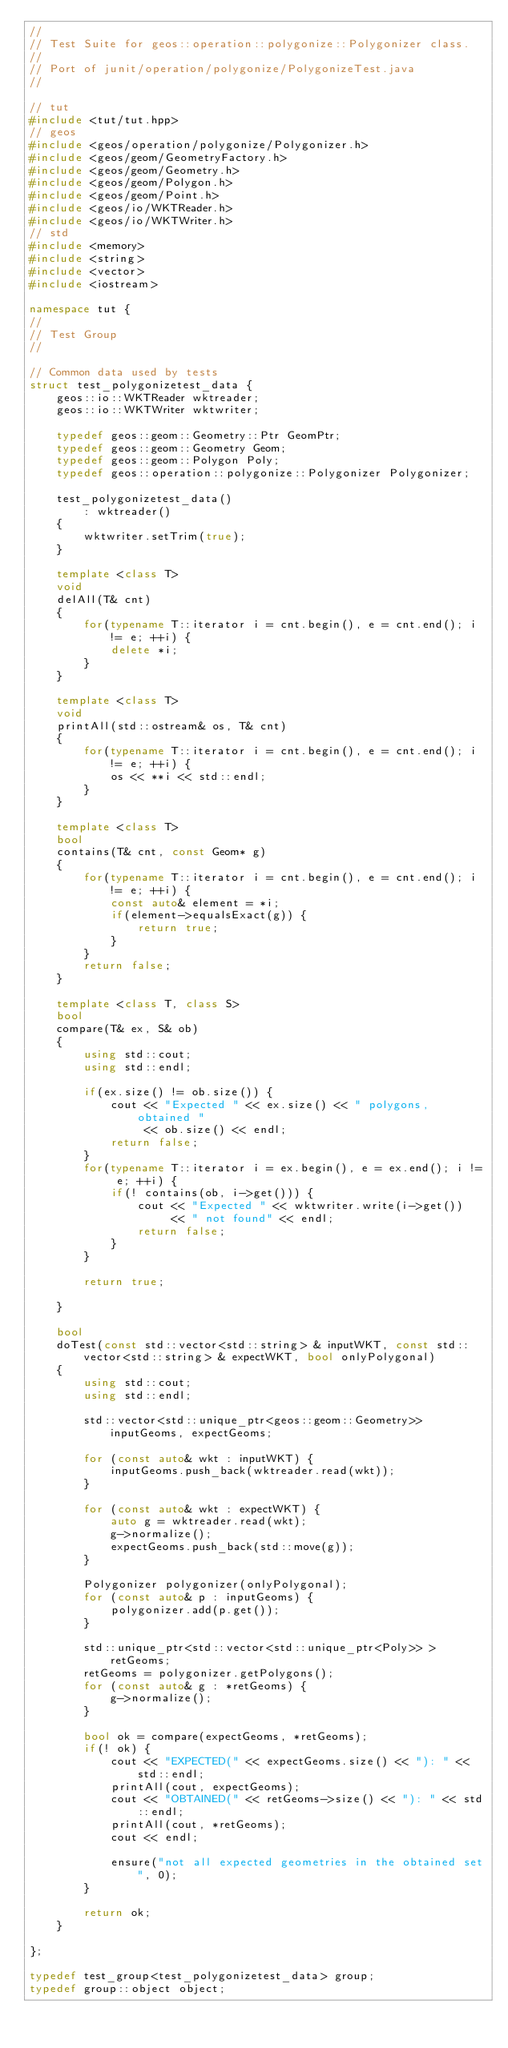<code> <loc_0><loc_0><loc_500><loc_500><_C++_>//
// Test Suite for geos::operation::polygonize::Polygonizer class.
//
// Port of junit/operation/polygonize/PolygonizeTest.java
//

// tut
#include <tut/tut.hpp>
// geos
#include <geos/operation/polygonize/Polygonizer.h>
#include <geos/geom/GeometryFactory.h>
#include <geos/geom/Geometry.h>
#include <geos/geom/Polygon.h>
#include <geos/geom/Point.h>
#include <geos/io/WKTReader.h>
#include <geos/io/WKTWriter.h>
// std
#include <memory>
#include <string>
#include <vector>
#include <iostream>

namespace tut {
//
// Test Group
//

// Common data used by tests
struct test_polygonizetest_data {
    geos::io::WKTReader wktreader;
    geos::io::WKTWriter wktwriter;

    typedef geos::geom::Geometry::Ptr GeomPtr;
    typedef geos::geom::Geometry Geom;
    typedef geos::geom::Polygon Poly;
    typedef geos::operation::polygonize::Polygonizer Polygonizer;

    test_polygonizetest_data()
        : wktreader()
    {
        wktwriter.setTrim(true);
    }

    template <class T>
    void
    delAll(T& cnt)
    {
        for(typename T::iterator i = cnt.begin(), e = cnt.end(); i != e; ++i) {
            delete *i;
        }
    }

    template <class T>
    void
    printAll(std::ostream& os, T& cnt)
    {
        for(typename T::iterator i = cnt.begin(), e = cnt.end(); i != e; ++i) {
            os << **i << std::endl;
        }
    }

    template <class T>
    bool
    contains(T& cnt, const Geom* g)
    {
        for(typename T::iterator i = cnt.begin(), e = cnt.end(); i != e; ++i) {
            const auto& element = *i;
            if(element->equalsExact(g)) {
                return true;
            }
        }
        return false;
    }

    template <class T, class S>
    bool
    compare(T& ex, S& ob)
    {
        using std::cout;
        using std::endl;

        if(ex.size() != ob.size()) {
            cout << "Expected " << ex.size() << " polygons, obtained "
                 << ob.size() << endl;
            return false;
        }
        for(typename T::iterator i = ex.begin(), e = ex.end(); i != e; ++i) {
            if(! contains(ob, i->get())) {
                cout << "Expected " << wktwriter.write(i->get())
                     << " not found" << endl;
                return false;
            }
        }

        return true;

    }

    bool
    doTest(const std::vector<std::string> & inputWKT, const std::vector<std::string> & expectWKT, bool onlyPolygonal)
    {
        using std::cout;
        using std::endl;

        std::vector<std::unique_ptr<geos::geom::Geometry>> inputGeoms, expectGeoms;

        for (const auto& wkt : inputWKT) {
            inputGeoms.push_back(wktreader.read(wkt));
        }

        for (const auto& wkt : expectWKT) {
            auto g = wktreader.read(wkt);
            g->normalize();
            expectGeoms.push_back(std::move(g));
        }

        Polygonizer polygonizer(onlyPolygonal);
        for (const auto& p : inputGeoms) {
            polygonizer.add(p.get());
        }

        std::unique_ptr<std::vector<std::unique_ptr<Poly>> > retGeoms;
        retGeoms = polygonizer.getPolygons();
        for (const auto& g : *retGeoms) {
            g->normalize();
        }

        bool ok = compare(expectGeoms, *retGeoms);
        if(! ok) {
            cout << "EXPECTED(" << expectGeoms.size() << "): " << std::endl;
            printAll(cout, expectGeoms);
            cout << "OBTAINED(" << retGeoms->size() << "): " << std::endl;
            printAll(cout, *retGeoms);
            cout << endl;

            ensure("not all expected geometries in the obtained set", 0);
        }

        return ok;
    }

};

typedef test_group<test_polygonizetest_data> group;
typedef group::object object;
</code> 